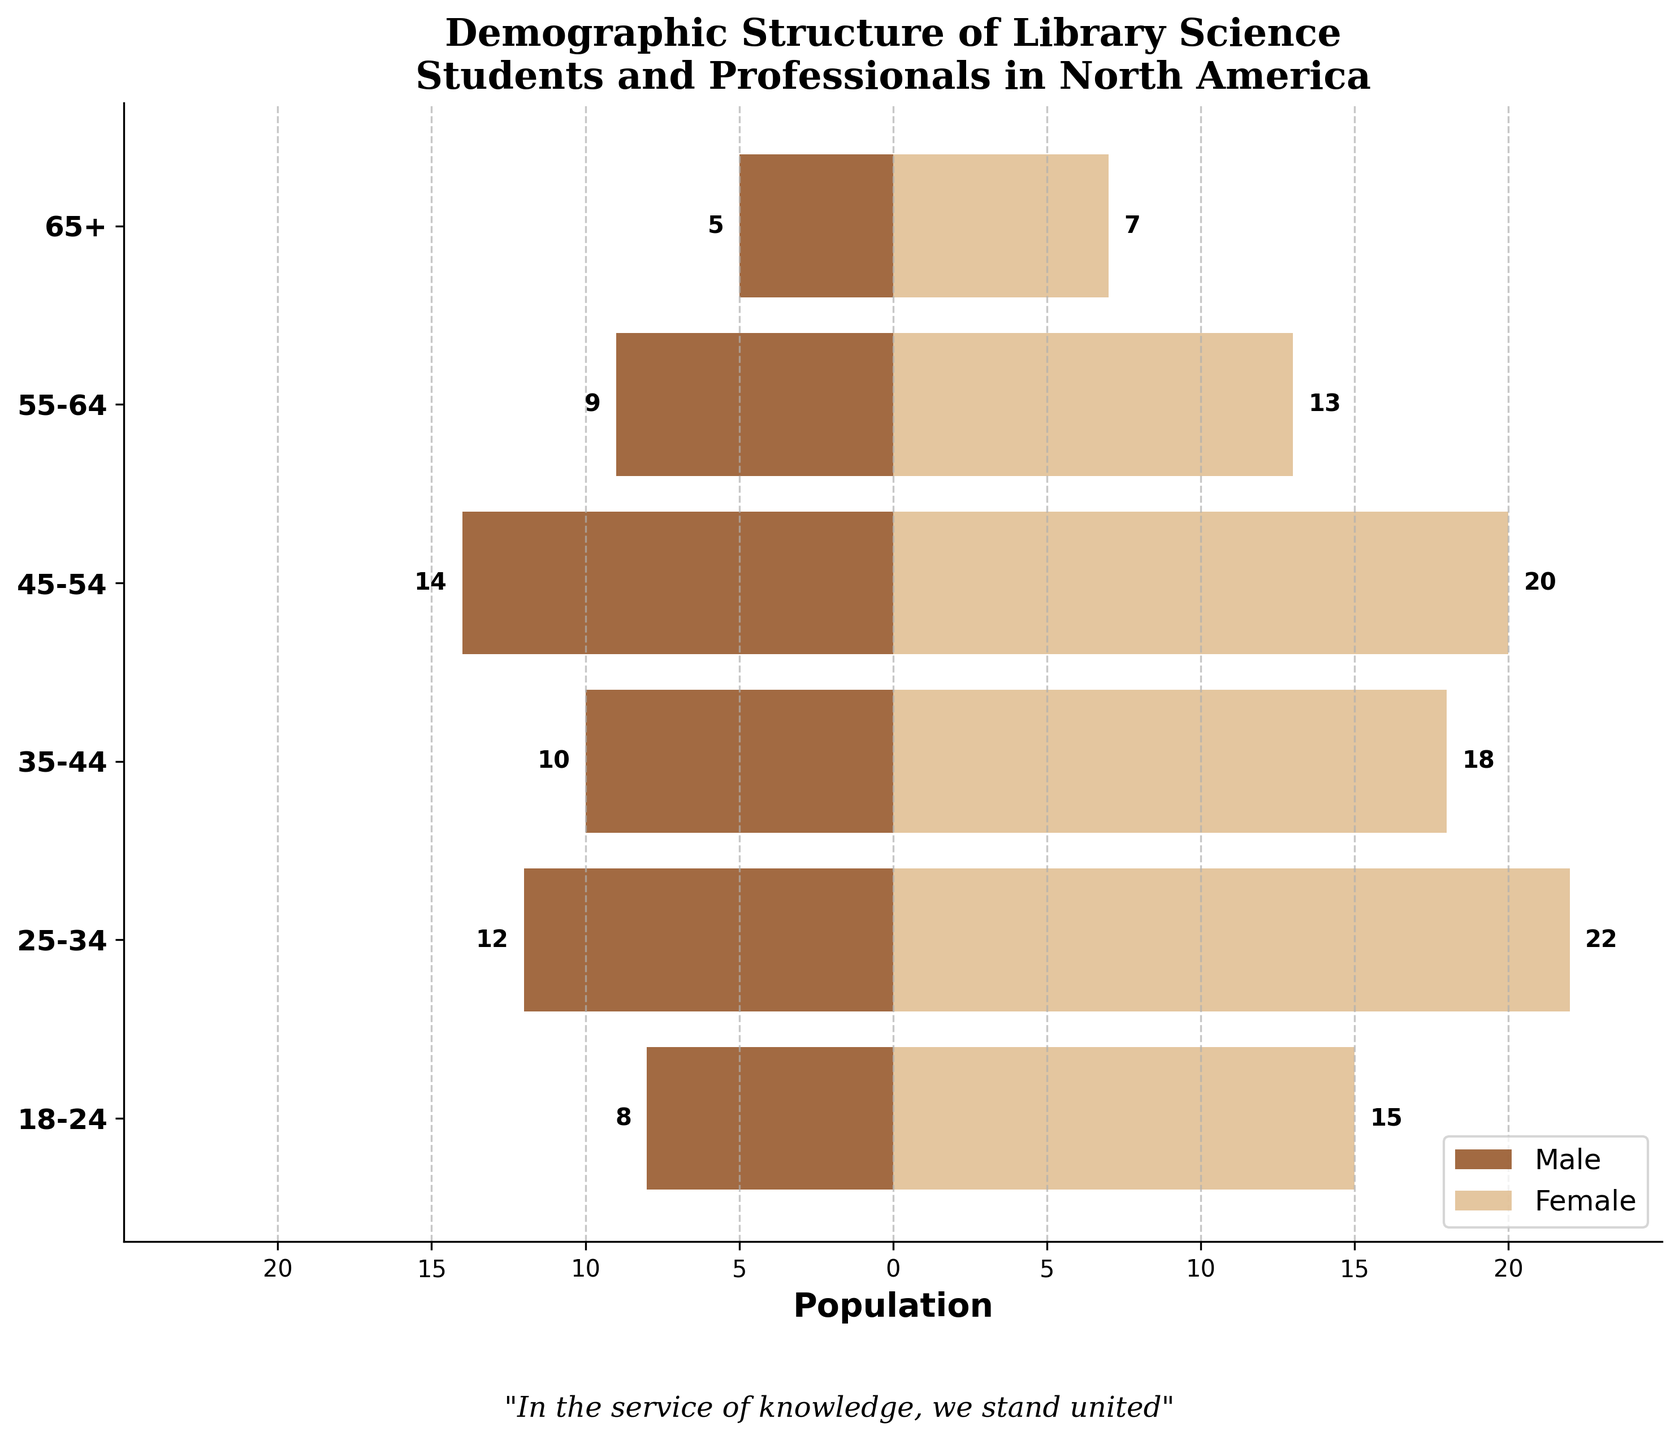How many age groups are represented in the population pyramid? The plot shows 6 different age groups on the y-axis, which range from 18-24 to 65+.
Answer: 6 Which age group has the highest number of female participants? By looking at the lengths of the female bars, the age group 25-34 has the longest bar, indicating the highest number of female participants.
Answer: 25-34 What's the difference in the number of males and females in the 45-54 age group? The figure shows 14 males and 20 females in the 45-54 age group. The difference is \(20 - 14 = 6\).
Answer: 6 Which age group has the smallest population for both males and females combined? For each age group, sum the male and female participants: \(18-24: 23\), \(25-34: 34\), \(35-44: 28\), \(45-54: 34\), \(55-64: 22\), and \(65+: 12\). The 65+ group has the smallest total population.
Answer: 65+ What is the total number of females across all age groups? Add the number of females in each age group: \(15 + 22 + 18 + 20 + 13 + 7 = 95\).
Answer: 95 Which gender has a higher total population in the 55-64 age group, and by how much? According to the figure, there are 13 females and 9 males in the 55-64 age group. The difference is \(13 - 9 = 4\). Females have a higher population by 4.
Answer: Females, by 4 Comparing the 18-24 and 25-34 age groups, which one shows a larger difference between the number of males and females? For the 18-24 group, the difference is \(15 - 8 = 7\). For the 25-34 group, the difference is \(22 - 12 = 10\). Thus, the 25-34 group shows a larger difference.
Answer: 25-34 What is the cumulative population for the 35-44 age group? Add the number of males and females in the 35-44 age group: \(10\) males and \(18\) females, which results in \(10 + 18 = 28\).
Answer: 28 What is the relationship between the number of males and females in the 18-24 and 65+ age groups? In the 18-24 group, there are 8 males and 15 females. In the 65+ group, there are 5 males and 7 females. Both show more females than males.
Answer: More females in both groups 